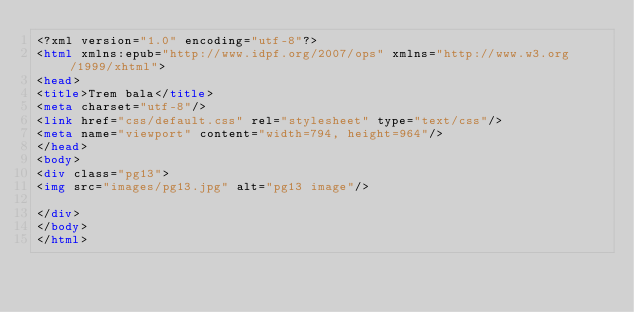Convert code to text. <code><loc_0><loc_0><loc_500><loc_500><_HTML_><?xml version="1.0" encoding="utf-8"?>
<html xmlns:epub="http://www.idpf.org/2007/ops" xmlns="http://www.w3.org/1999/xhtml">
<head>
<title>Trem bala</title>
<meta charset="utf-8"/>
<link href="css/default.css" rel="stylesheet" type="text/css"/>
<meta name="viewport" content="width=794, height=964"/>
</head>
<body>
<div class="pg13">
<img src="images/pg13.jpg" alt="pg13 image"/>

</div>
</body>
</html>
</code> 